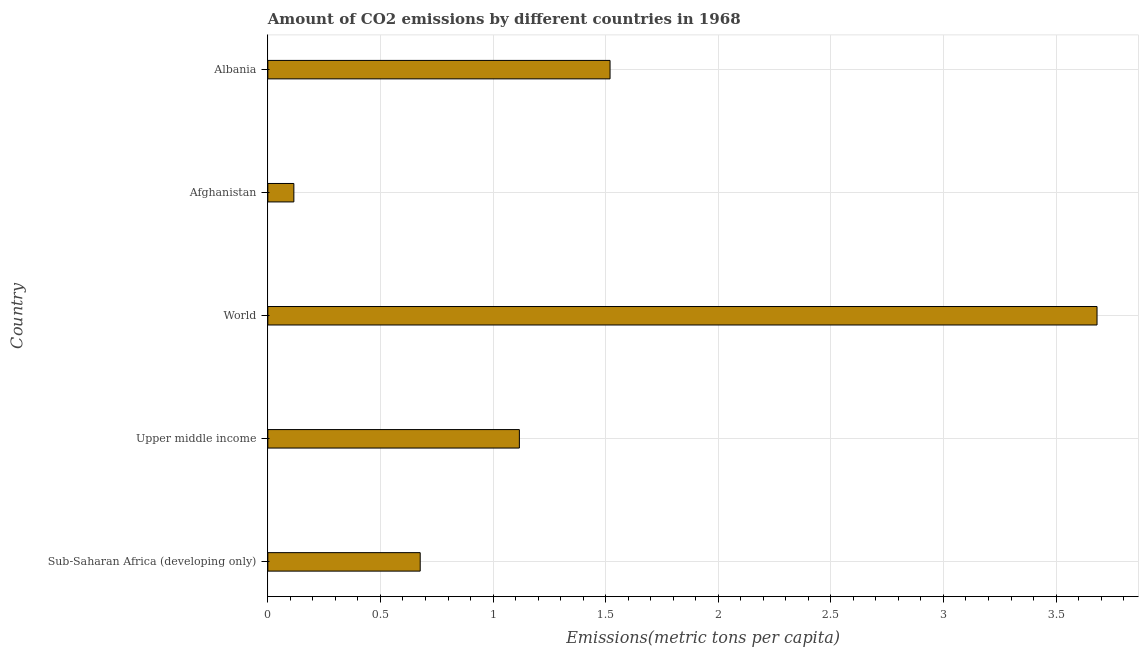Does the graph contain any zero values?
Give a very brief answer. No. Does the graph contain grids?
Keep it short and to the point. Yes. What is the title of the graph?
Make the answer very short. Amount of CO2 emissions by different countries in 1968. What is the label or title of the X-axis?
Provide a short and direct response. Emissions(metric tons per capita). What is the amount of co2 emissions in Upper middle income?
Ensure brevity in your answer.  1.12. Across all countries, what is the maximum amount of co2 emissions?
Keep it short and to the point. 3.68. Across all countries, what is the minimum amount of co2 emissions?
Provide a succinct answer. 0.12. In which country was the amount of co2 emissions minimum?
Give a very brief answer. Afghanistan. What is the sum of the amount of co2 emissions?
Offer a terse response. 7.11. What is the difference between the amount of co2 emissions in Upper middle income and World?
Your response must be concise. -2.56. What is the average amount of co2 emissions per country?
Give a very brief answer. 1.42. What is the median amount of co2 emissions?
Make the answer very short. 1.12. In how many countries, is the amount of co2 emissions greater than 3.6 metric tons per capita?
Your answer should be compact. 1. What is the ratio of the amount of co2 emissions in Albania to that in Sub-Saharan Africa (developing only)?
Your answer should be very brief. 2.25. Is the amount of co2 emissions in Afghanistan less than that in World?
Your answer should be compact. Yes. Is the difference between the amount of co2 emissions in Sub-Saharan Africa (developing only) and Upper middle income greater than the difference between any two countries?
Offer a terse response. No. What is the difference between the highest and the second highest amount of co2 emissions?
Your answer should be compact. 2.16. What is the difference between the highest and the lowest amount of co2 emissions?
Your answer should be very brief. 3.57. How many bars are there?
Provide a succinct answer. 5. How many countries are there in the graph?
Make the answer very short. 5. What is the difference between two consecutive major ticks on the X-axis?
Ensure brevity in your answer.  0.5. What is the Emissions(metric tons per capita) in Sub-Saharan Africa (developing only)?
Keep it short and to the point. 0.68. What is the Emissions(metric tons per capita) of Upper middle income?
Offer a very short reply. 1.12. What is the Emissions(metric tons per capita) in World?
Provide a short and direct response. 3.68. What is the Emissions(metric tons per capita) of Afghanistan?
Your response must be concise. 0.12. What is the Emissions(metric tons per capita) of Albania?
Make the answer very short. 1.52. What is the difference between the Emissions(metric tons per capita) in Sub-Saharan Africa (developing only) and Upper middle income?
Your response must be concise. -0.44. What is the difference between the Emissions(metric tons per capita) in Sub-Saharan Africa (developing only) and World?
Provide a succinct answer. -3.01. What is the difference between the Emissions(metric tons per capita) in Sub-Saharan Africa (developing only) and Afghanistan?
Keep it short and to the point. 0.56. What is the difference between the Emissions(metric tons per capita) in Sub-Saharan Africa (developing only) and Albania?
Provide a short and direct response. -0.84. What is the difference between the Emissions(metric tons per capita) in Upper middle income and World?
Provide a short and direct response. -2.57. What is the difference between the Emissions(metric tons per capita) in Upper middle income and Afghanistan?
Give a very brief answer. 1. What is the difference between the Emissions(metric tons per capita) in Upper middle income and Albania?
Your response must be concise. -0.4. What is the difference between the Emissions(metric tons per capita) in World and Afghanistan?
Offer a very short reply. 3.57. What is the difference between the Emissions(metric tons per capita) in World and Albania?
Offer a very short reply. 2.16. What is the difference between the Emissions(metric tons per capita) in Afghanistan and Albania?
Your answer should be compact. -1.4. What is the ratio of the Emissions(metric tons per capita) in Sub-Saharan Africa (developing only) to that in Upper middle income?
Your response must be concise. 0.61. What is the ratio of the Emissions(metric tons per capita) in Sub-Saharan Africa (developing only) to that in World?
Your response must be concise. 0.18. What is the ratio of the Emissions(metric tons per capita) in Sub-Saharan Africa (developing only) to that in Afghanistan?
Ensure brevity in your answer.  5.86. What is the ratio of the Emissions(metric tons per capita) in Sub-Saharan Africa (developing only) to that in Albania?
Offer a terse response. 0.45. What is the ratio of the Emissions(metric tons per capita) in Upper middle income to that in World?
Offer a very short reply. 0.3. What is the ratio of the Emissions(metric tons per capita) in Upper middle income to that in Afghanistan?
Make the answer very short. 9.67. What is the ratio of the Emissions(metric tons per capita) in Upper middle income to that in Albania?
Provide a short and direct response. 0.73. What is the ratio of the Emissions(metric tons per capita) in World to that in Afghanistan?
Offer a terse response. 31.86. What is the ratio of the Emissions(metric tons per capita) in World to that in Albania?
Your answer should be very brief. 2.42. What is the ratio of the Emissions(metric tons per capita) in Afghanistan to that in Albania?
Offer a very short reply. 0.08. 